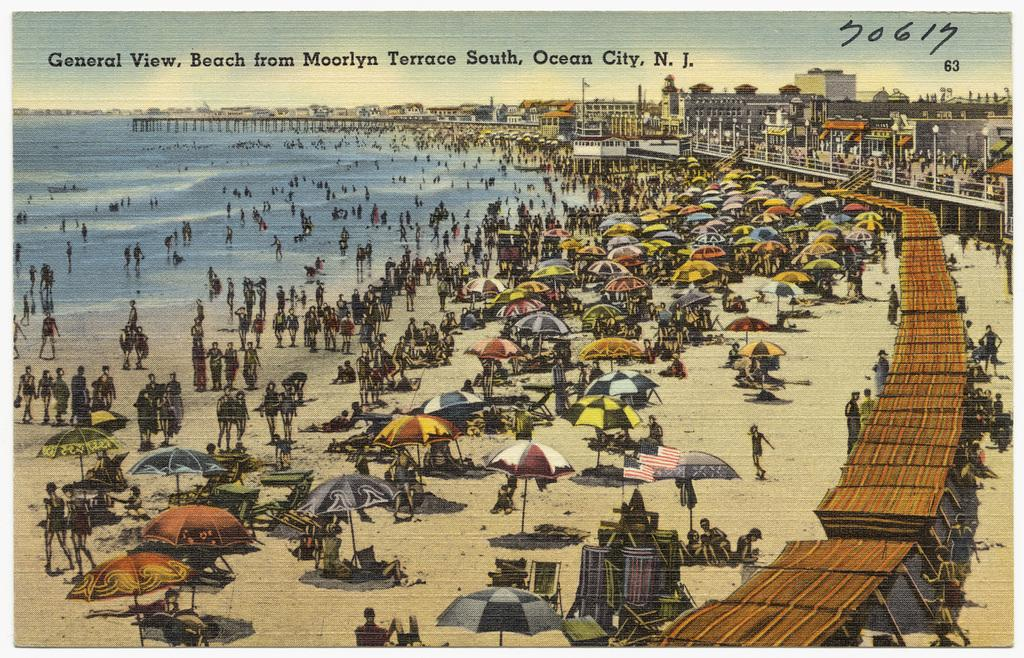<image>
Describe the image concisely. a beach general view of the beach from moorlyn terrace south 